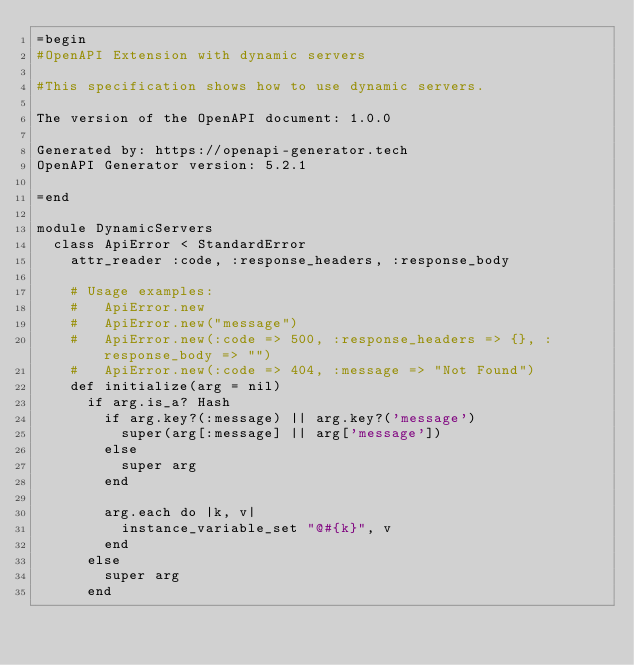Convert code to text. <code><loc_0><loc_0><loc_500><loc_500><_Ruby_>=begin
#OpenAPI Extension with dynamic servers

#This specification shows how to use dynamic servers.

The version of the OpenAPI document: 1.0.0

Generated by: https://openapi-generator.tech
OpenAPI Generator version: 5.2.1

=end

module DynamicServers
  class ApiError < StandardError
    attr_reader :code, :response_headers, :response_body

    # Usage examples:
    #   ApiError.new
    #   ApiError.new("message")
    #   ApiError.new(:code => 500, :response_headers => {}, :response_body => "")
    #   ApiError.new(:code => 404, :message => "Not Found")
    def initialize(arg = nil)
      if arg.is_a? Hash
        if arg.key?(:message) || arg.key?('message')
          super(arg[:message] || arg['message'])
        else
          super arg
        end

        arg.each do |k, v|
          instance_variable_set "@#{k}", v
        end
      else
        super arg
      end</code> 